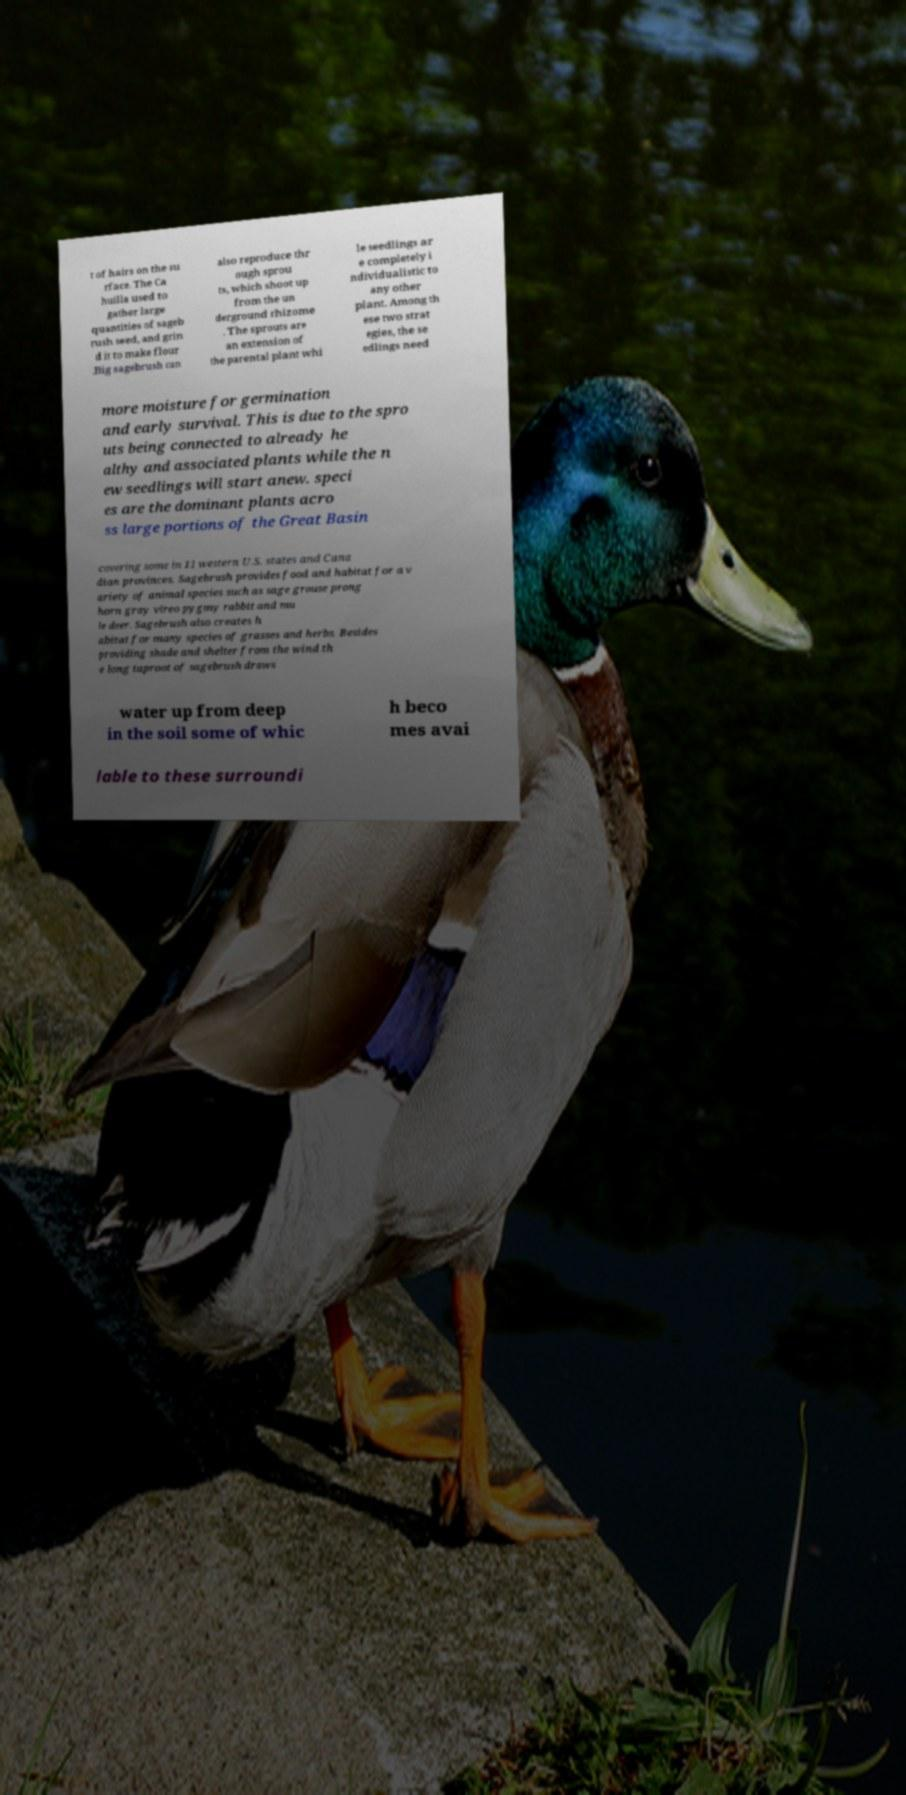Could you assist in decoding the text presented in this image and type it out clearly? t of hairs on the su rface. The Ca huilla used to gather large quantities of sageb rush seed, and grin d it to make flour .Big sagebrush can also reproduce thr ough sprou ts, which shoot up from the un derground rhizome . The sprouts are an extension of the parental plant whi le seedlings ar e completely i ndividualistic to any other plant. Among th ese two strat egies, the se edlings need more moisture for germination and early survival. This is due to the spro uts being connected to already he althy and associated plants while the n ew seedlings will start anew. speci es are the dominant plants acro ss large portions of the Great Basin covering some in 11 western U.S. states and Cana dian provinces. Sagebrush provides food and habitat for a v ariety of animal species such as sage grouse prong horn gray vireo pygmy rabbit and mu le deer. Sagebrush also creates h abitat for many species of grasses and herbs. Besides providing shade and shelter from the wind th e long taproot of sagebrush draws water up from deep in the soil some of whic h beco mes avai lable to these surroundi 